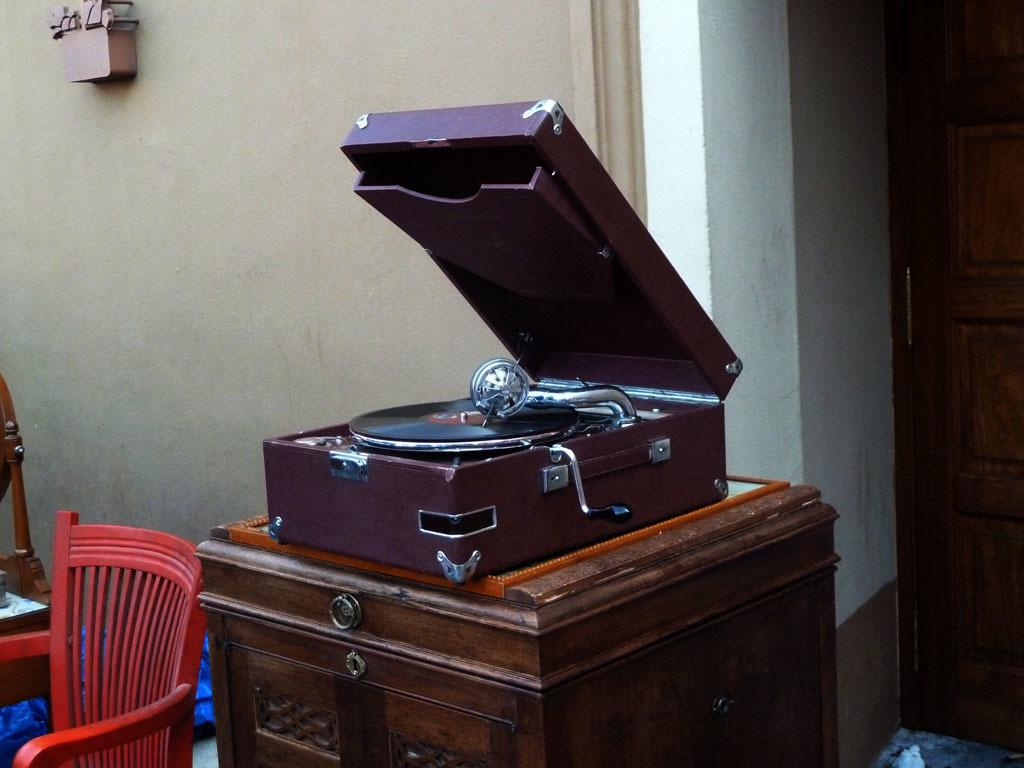What type of furniture is in the image? There is a gramophone cabinet in the image. Where is the chair located in the image? The chair is on the right side of the image. What can be seen on the wall in the image? There is an object on the wall in the image. What architectural feature is visible in the background of the image? A door is visible in the background of the image. What type of powder is being used to clean the gramophone cabinet in the image? There is no indication of any cleaning activity or powder in the image; it only shows a gramophone cabinet, a chair, an object on the wall, and a door in the background. 